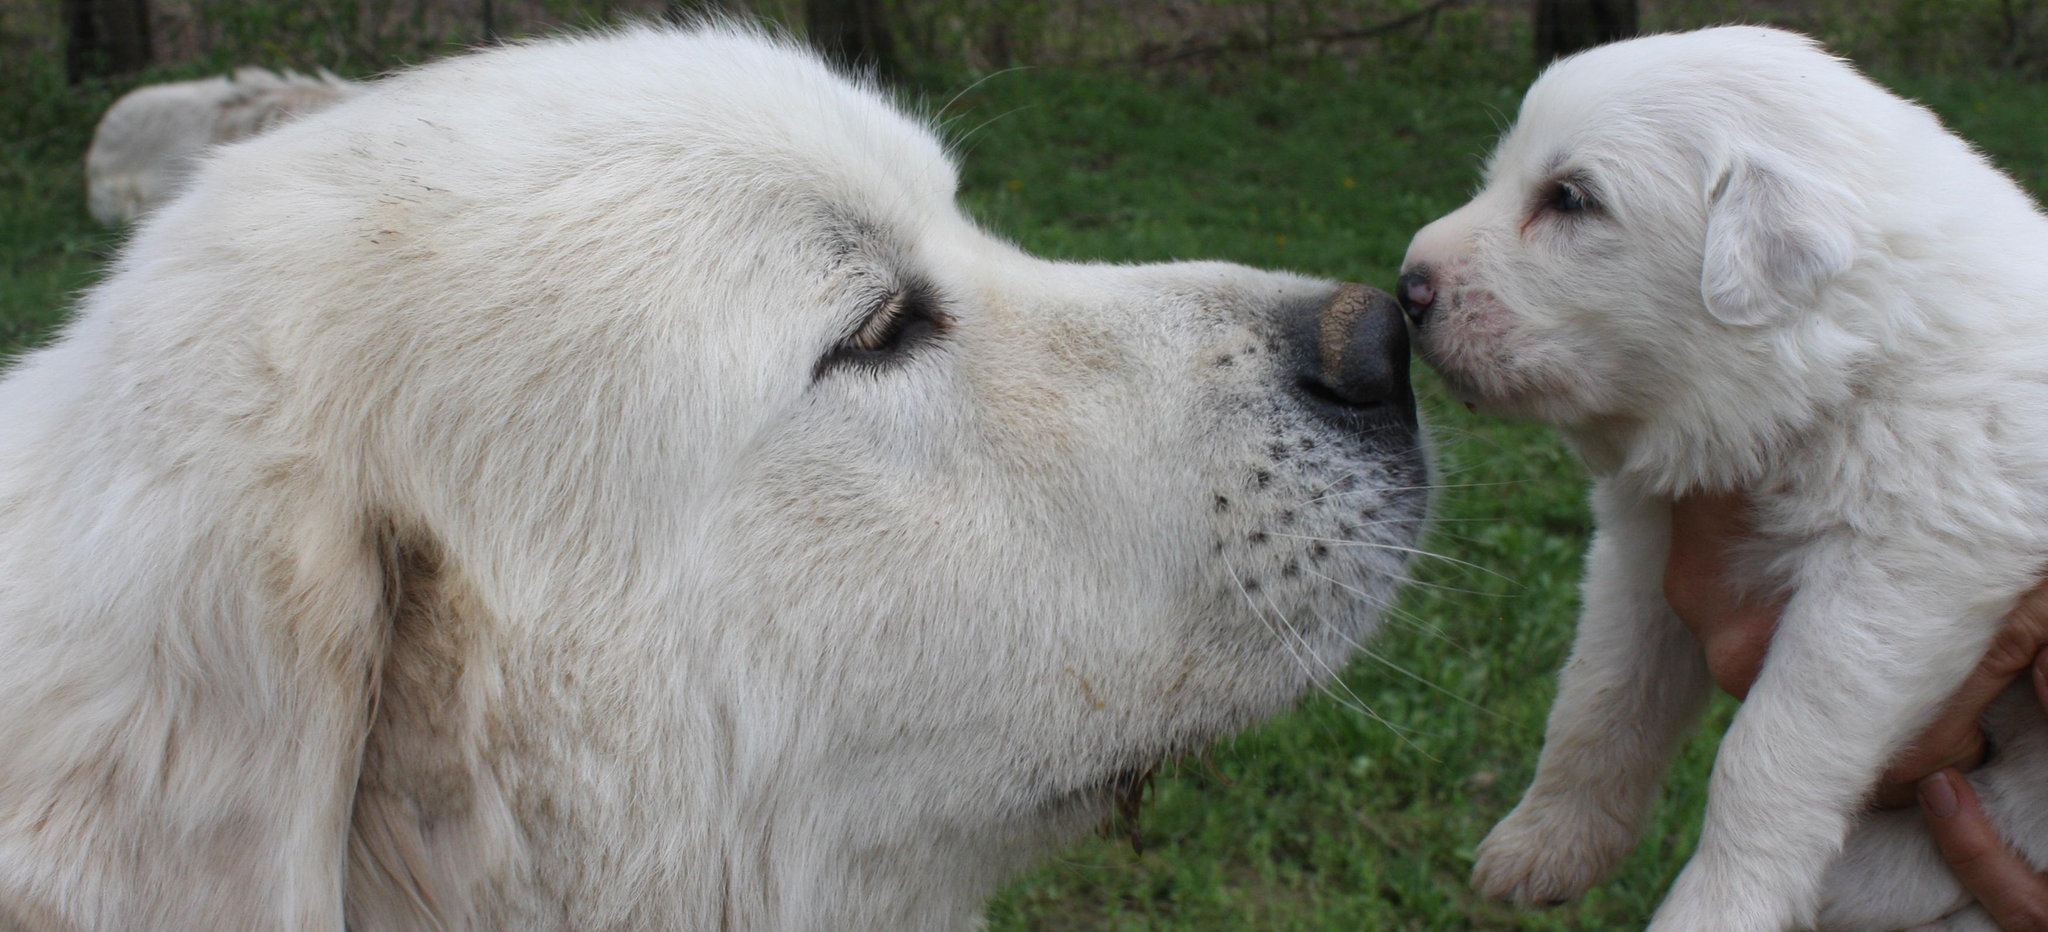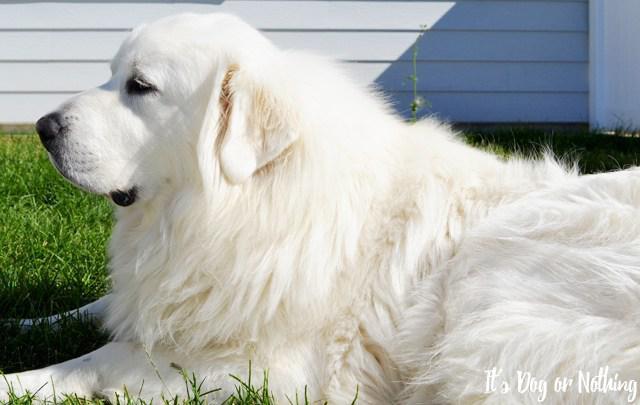The first image is the image on the left, the second image is the image on the right. For the images shown, is this caption "At least one dog in an image in the pair has its mouth open and tongue visible." true? Answer yes or no. No. The first image is the image on the left, the second image is the image on the right. Given the left and right images, does the statement "There are no more than two white dogs." hold true? Answer yes or no. No. 